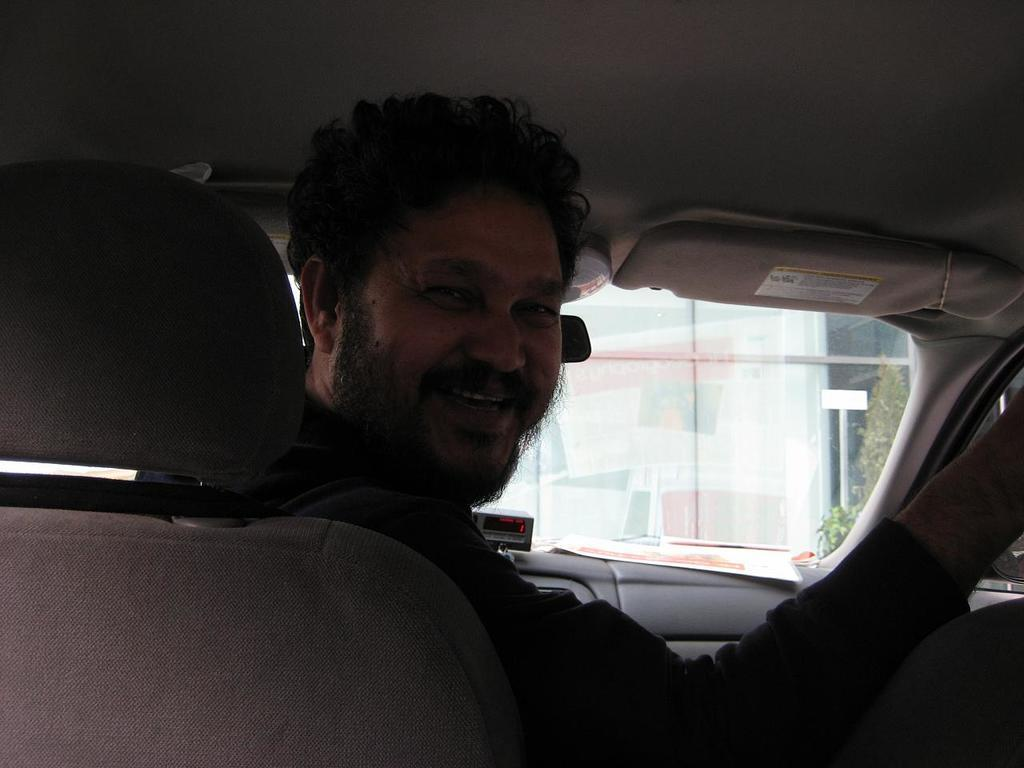Who is present in the image? There is a man in the image. What is the man doing in the image? The man is smiling in the image. What is the man wearing in the image? The man is wearing a black jacket in the image. Where is the man located in the image? The man is sitting in a car in the image. What type of haircut does the deer have in the image? There is no deer present in the image, and therefore no haircut can be observed. How does the man tie a knot with the car in the image? The man is not tying a knot with the car in the image; he is simply sitting in it. 